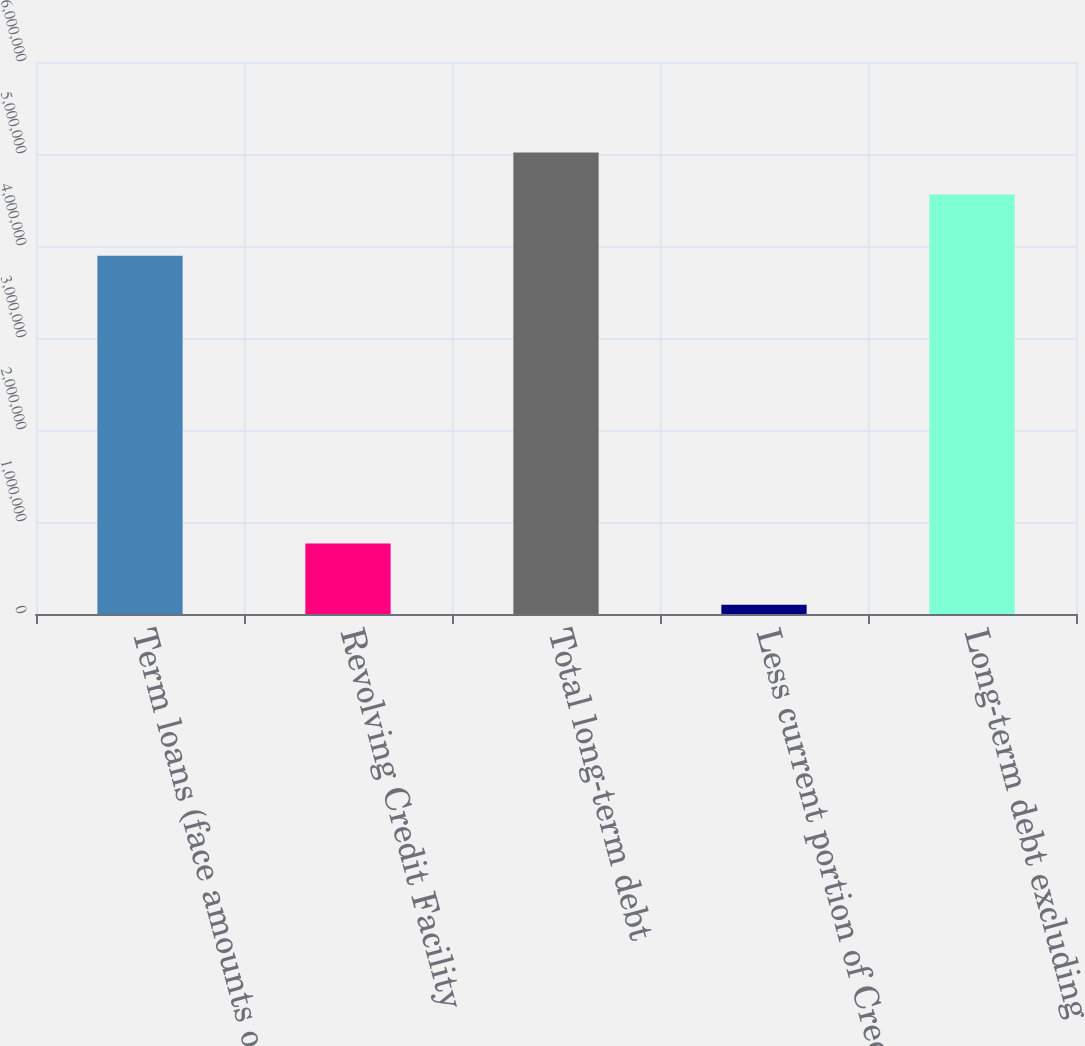Convert chart to OTSL. <chart><loc_0><loc_0><loc_500><loc_500><bar_chart><fcel>Term loans (face amounts of<fcel>Revolving Credit Facility<fcel>Total long-term debt<fcel>Less current portion of Credit<fcel>Long-term debt excluding<nl><fcel>3.89472e+06<fcel>765000<fcel>5.01535e+06<fcel>100308<fcel>4.55941e+06<nl></chart> 